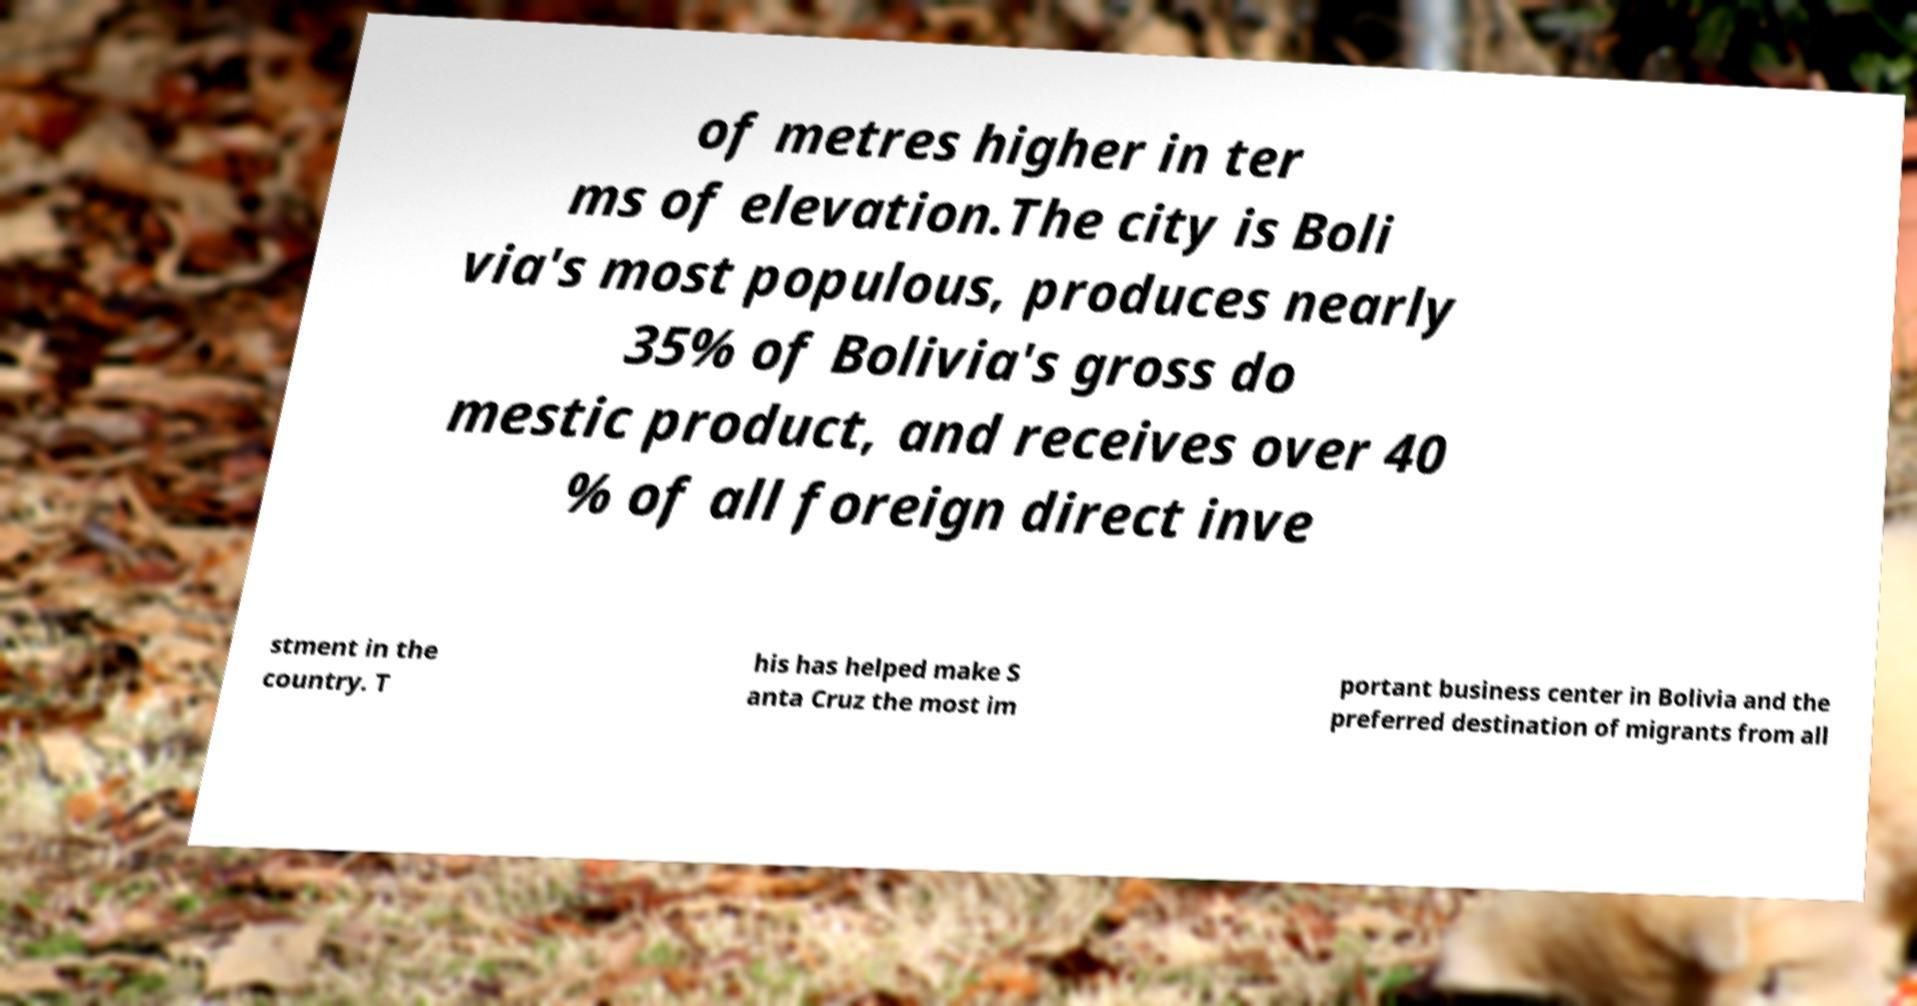Could you extract and type out the text from this image? of metres higher in ter ms of elevation.The city is Boli via's most populous, produces nearly 35% of Bolivia's gross do mestic product, and receives over 40 % of all foreign direct inve stment in the country. T his has helped make S anta Cruz the most im portant business center in Bolivia and the preferred destination of migrants from all 